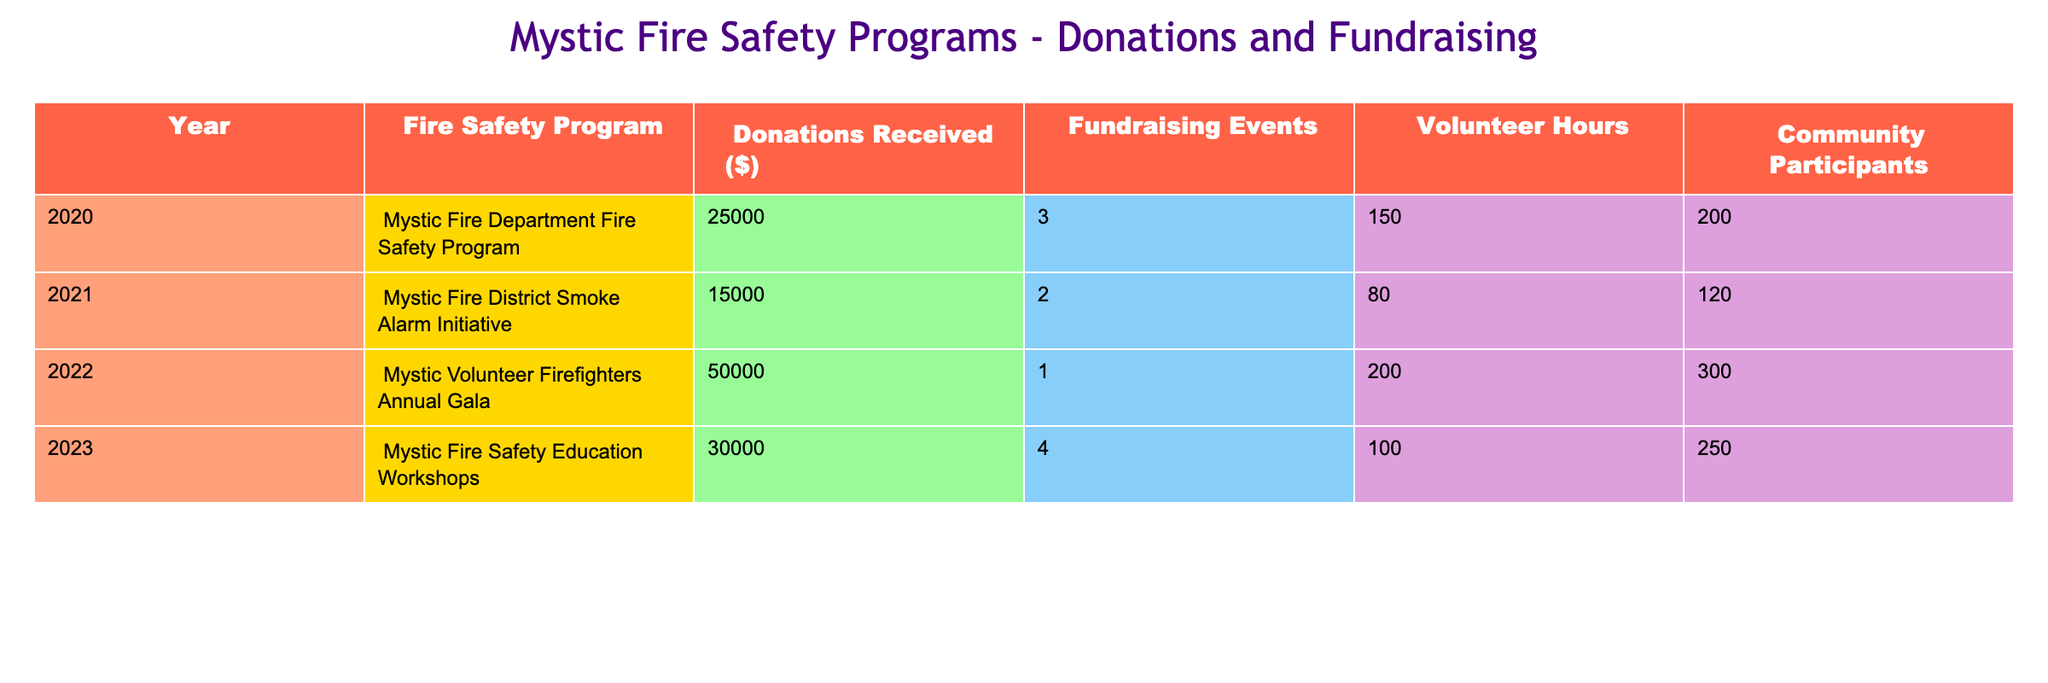What was the highest amount of donations received for a fire safety program in Mystic? The highest amount of donations in the table is in 2022 for the Mystic Volunteer Firefighters Annual Gala, which received 50000 dollars.
Answer: 50000 How many fundraising events were held in total from 2020 to 2023? The total number of fundraising events can be calculated by adding the events from each year: 3 (2020) + 2 (2021) + 1 (2022) + 4 (2023) = 10 events in total.
Answer: 10 Did the Mystic Fire Safety Education Workshops have more community participants than the Mystic Volunteer Firefighters Annual Gala? The Mystic Fire Safety Education Workshops had 250 participants, while the Annual Gala had 300 participants. Since 250 is less than 300, the statement is false.
Answer: No What is the average number of volunteer hours across all fire safety programs listed? To find the average, we add the volunteer hours: 150 + 80 + 200 + 100 = 530 total hours, then divide by the number of programs (4), giving us an average of 530/4 = 132.5 hours.
Answer: 132.5 In which year did the Mystic Fire Department Fire Safety Program receive 25000 dollars in donations? Referring to the table, the Mystic Fire Department Fire Safety Program received 25000 dollars in donations in the year 2020.
Answer: 2020 Which fire safety program had the fewest volunteer hours? The program with the fewest volunteer hours is the Mystic District Smoke Alarm Initiative, which had 80 volunteer hours.
Answer: Mystic District Smoke Alarm Initiative What was the difference in donations between the Mystic Volunteer Firefighters Annual Gala and the Mystic Fire District Smoke Alarm Initiative? The difference in donations is calculated by subtracting the 15000 dollars received by the Smoke Alarm Initiative from the 50000 dollars received by the Annual Gala: 50000 - 15000 = 35000 dollars.
Answer: 35000 Was there a year when more than three fundraising events were organized? Yes, in 2023, there were four fundraising events organized for the Mystic Fire Safety Education Workshops.
Answer: Yes Calculate the total amount of donations received over the four years. To find the total, sum the donations from each year: 25000 + 15000 + 50000 + 30000 = 120000 dollars in total donations received over four years.
Answer: 120000 